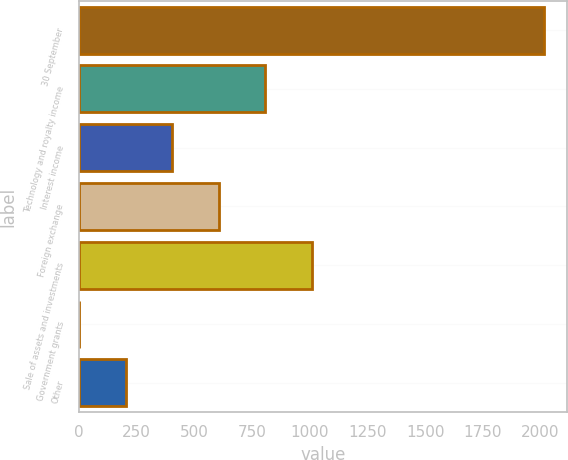Convert chart. <chart><loc_0><loc_0><loc_500><loc_500><bar_chart><fcel>30 September<fcel>Technology and royalty income<fcel>Interest income<fcel>Foreign exchange<fcel>Sale of assets and investments<fcel>Government grants<fcel>Other<nl><fcel>2015<fcel>806.6<fcel>403.8<fcel>605.2<fcel>1008<fcel>1<fcel>202.4<nl></chart> 